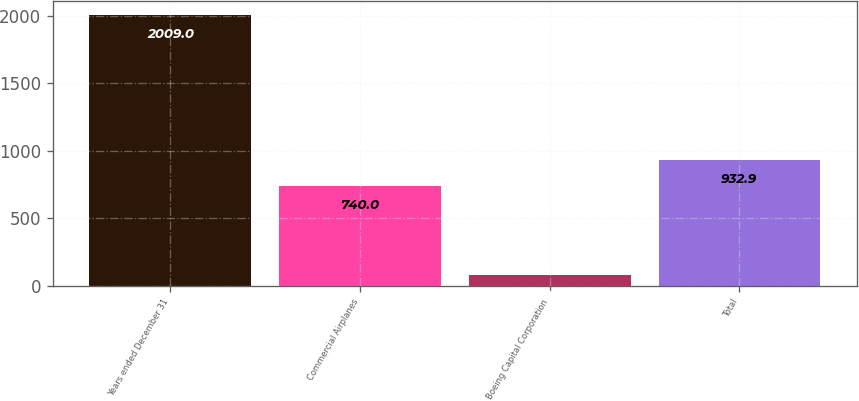<chart> <loc_0><loc_0><loc_500><loc_500><bar_chart><fcel>Years ended December 31<fcel>Commercial Airplanes<fcel>Boeing Capital Corporation<fcel>Total<nl><fcel>2009<fcel>740<fcel>80<fcel>932.9<nl></chart> 